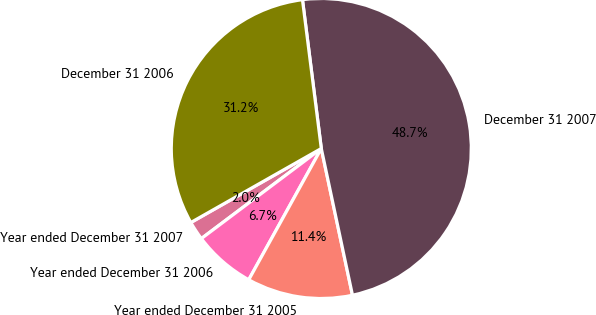Convert chart. <chart><loc_0><loc_0><loc_500><loc_500><pie_chart><fcel>Year ended December 31 2007<fcel>Year ended December 31 2006<fcel>Year ended December 31 2005<fcel>December 31 2007<fcel>December 31 2006<nl><fcel>2.04%<fcel>6.71%<fcel>11.37%<fcel>48.67%<fcel>31.21%<nl></chart> 